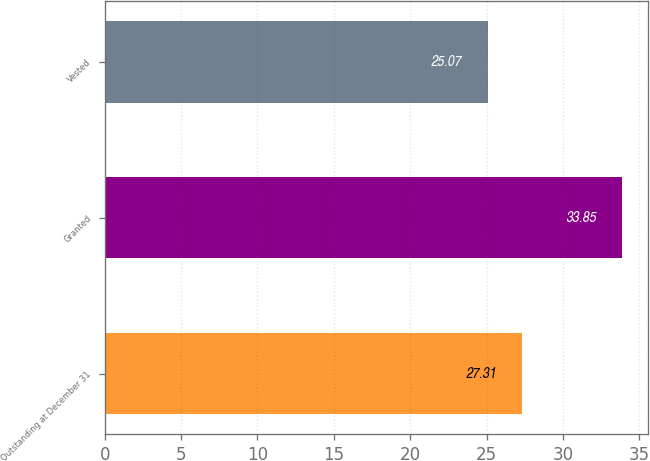<chart> <loc_0><loc_0><loc_500><loc_500><bar_chart><fcel>Outstanding at December 31<fcel>Granted<fcel>Vested<nl><fcel>27.31<fcel>33.85<fcel>25.07<nl></chart> 